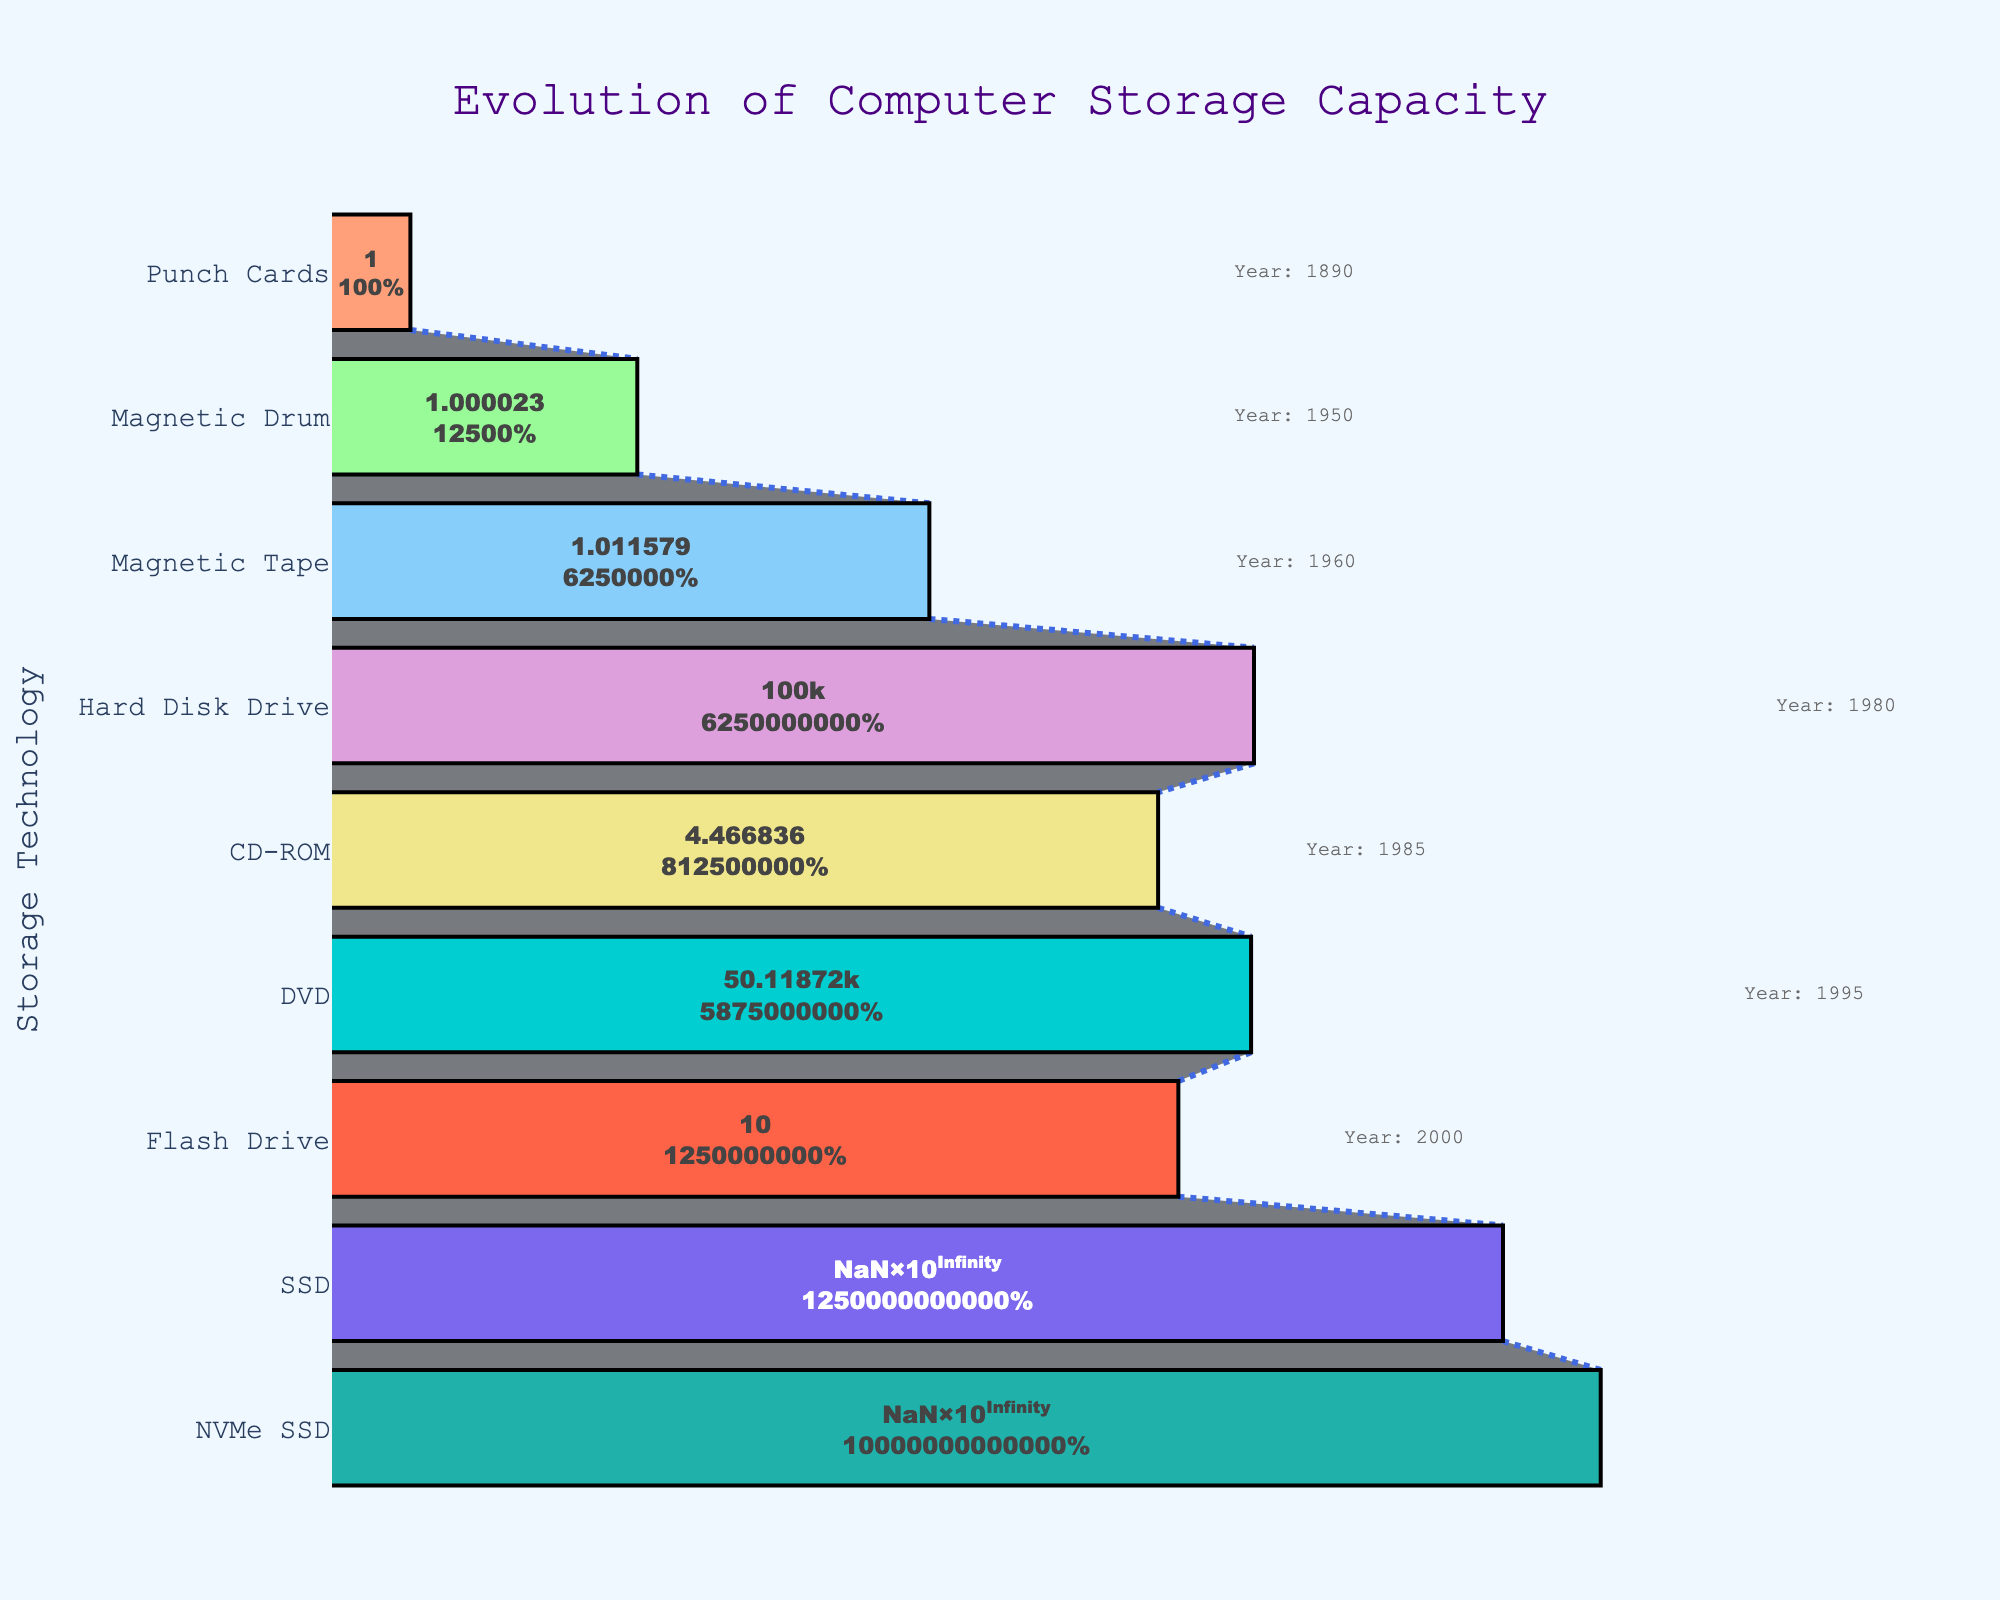What is the title of the figure? The title appears prominently at the top of the figure and usually provides a summary of what the chart represents.
Answer: Evolution of Computer Storage Capacity How many stages of computer storage technologies are shown in the figure? The y-axis lists each stage of computer storage technology; counting these will give the answer.
Answer: 9 Which stage represents the highest storage capacity in the chart? The x-axis shows the storage capacities. The highest capacity will be the widest part of the funnel chart.
Answer: NVMe SSD What is the storage capacity Difference between Hard Disk Drive and DVD? Locate both HDD and DVD on the y-axis and note their corresponding storage capacities on the x-axis. Subtract the smaller value (DVD) from the larger value (HDD).
Answer: 3 GB What is the total storage capacity of all the technologies combined, rounded to the nearest whole number? Sum the storage capacities of each technology listed on the x-axis. Values need to be converted from GB if still in Bytes.
Answer: 8,271,650,761,080 Bytes Which technology was introduced earliest, and what was its storage capacity? Check the annotation mentioning the earliest year on the chart; this will give the corresponding technology and its storage capacity from the x-axis.
Answer: Punch Cards, 80 Bytes How many years are illustrated between the oldest and the latest storage technology in the figure? Find the year annotations for the oldest (Punch Cards) and the latest (NVMe SSD) technologies. Subtract the former's year from the latter's year.
Answer: 130 years What is the average storage capacity in GB across all the presented storage technologies? Add up all the storage capacities in GB from the x-axis and divide by the number of technologies (9).
Answer: ~917,639.53 GB Which storage technology saw the largest increase in capacity compared to its immediate predecessor? Compare the difference in storage capacities between each pair of consecutive technologies on the y-axis; the pair with the largest difference gives the answer.
Answer: SSD (compared to Flash Drive) Is there any stage where storage capacity decreases compared to the technology that came before it? Examine the x-axis values of each pair of consecutive y-axis stages to check if any later stage has a smaller x-value than the one before it.
Answer: No 